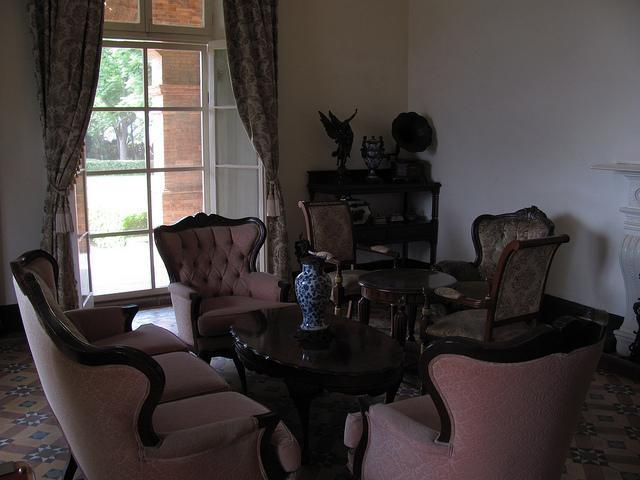How many couches are there?
Give a very brief answer. 3. How many chairs are visible?
Give a very brief answer. 5. How many clocks are shown?
Give a very brief answer. 0. 